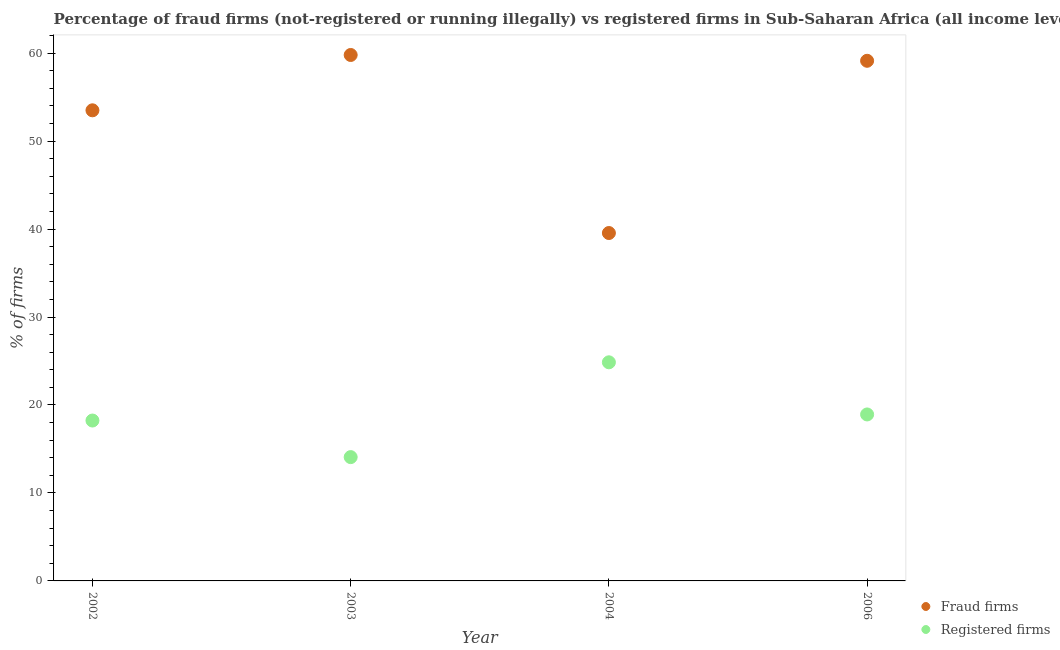How many different coloured dotlines are there?
Offer a very short reply. 2. Is the number of dotlines equal to the number of legend labels?
Offer a very short reply. Yes. What is the percentage of registered firms in 2002?
Provide a short and direct response. 18.23. Across all years, what is the maximum percentage of registered firms?
Offer a very short reply. 24.85. Across all years, what is the minimum percentage of fraud firms?
Give a very brief answer. 39.55. In which year was the percentage of fraud firms minimum?
Your response must be concise. 2004. What is the total percentage of fraud firms in the graph?
Your answer should be compact. 211.97. What is the difference between the percentage of registered firms in 2003 and that in 2006?
Offer a terse response. -4.85. What is the difference between the percentage of registered firms in 2003 and the percentage of fraud firms in 2004?
Your answer should be very brief. -25.47. What is the average percentage of registered firms per year?
Make the answer very short. 19.02. In the year 2002, what is the difference between the percentage of fraud firms and percentage of registered firms?
Your answer should be compact. 35.27. What is the ratio of the percentage of registered firms in 2004 to that in 2006?
Your answer should be compact. 1.31. Is the difference between the percentage of registered firms in 2003 and 2004 greater than the difference between the percentage of fraud firms in 2003 and 2004?
Give a very brief answer. No. What is the difference between the highest and the second highest percentage of registered firms?
Make the answer very short. 5.93. What is the difference between the highest and the lowest percentage of fraud firms?
Your response must be concise. 20.24. Is the sum of the percentage of fraud firms in 2002 and 2006 greater than the maximum percentage of registered firms across all years?
Ensure brevity in your answer.  Yes. Does the percentage of fraud firms monotonically increase over the years?
Give a very brief answer. No. Is the percentage of registered firms strictly greater than the percentage of fraud firms over the years?
Ensure brevity in your answer.  No. Is the percentage of fraud firms strictly less than the percentage of registered firms over the years?
Ensure brevity in your answer.  No. How many dotlines are there?
Your response must be concise. 2. Are the values on the major ticks of Y-axis written in scientific E-notation?
Your response must be concise. No. Does the graph contain any zero values?
Your answer should be compact. No. Does the graph contain grids?
Your answer should be compact. No. How many legend labels are there?
Give a very brief answer. 2. How are the legend labels stacked?
Keep it short and to the point. Vertical. What is the title of the graph?
Your answer should be very brief. Percentage of fraud firms (not-registered or running illegally) vs registered firms in Sub-Saharan Africa (all income levels). Does "Nitrous oxide" appear as one of the legend labels in the graph?
Your answer should be very brief. No. What is the label or title of the X-axis?
Offer a terse response. Year. What is the label or title of the Y-axis?
Keep it short and to the point. % of firms. What is the % of firms of Fraud firms in 2002?
Your answer should be very brief. 53.5. What is the % of firms in Registered firms in 2002?
Offer a terse response. 18.23. What is the % of firms in Fraud firms in 2003?
Keep it short and to the point. 59.79. What is the % of firms in Registered firms in 2003?
Your answer should be very brief. 14.07. What is the % of firms in Fraud firms in 2004?
Make the answer very short. 39.55. What is the % of firms in Registered firms in 2004?
Ensure brevity in your answer.  24.85. What is the % of firms of Fraud firms in 2006?
Your response must be concise. 59.13. What is the % of firms in Registered firms in 2006?
Offer a terse response. 18.93. Across all years, what is the maximum % of firms of Fraud firms?
Your answer should be compact. 59.79. Across all years, what is the maximum % of firms in Registered firms?
Offer a very short reply. 24.85. Across all years, what is the minimum % of firms in Fraud firms?
Ensure brevity in your answer.  39.55. Across all years, what is the minimum % of firms of Registered firms?
Offer a very short reply. 14.07. What is the total % of firms in Fraud firms in the graph?
Ensure brevity in your answer.  211.97. What is the total % of firms in Registered firms in the graph?
Make the answer very short. 76.09. What is the difference between the % of firms of Fraud firms in 2002 and that in 2003?
Make the answer very short. -6.29. What is the difference between the % of firms in Registered firms in 2002 and that in 2003?
Your answer should be very brief. 4.16. What is the difference between the % of firms of Fraud firms in 2002 and that in 2004?
Provide a succinct answer. 13.95. What is the difference between the % of firms in Registered firms in 2002 and that in 2004?
Give a very brief answer. -6.62. What is the difference between the % of firms of Fraud firms in 2002 and that in 2006?
Give a very brief answer. -5.63. What is the difference between the % of firms of Registered firms in 2002 and that in 2006?
Give a very brief answer. -0.69. What is the difference between the % of firms of Fraud firms in 2003 and that in 2004?
Make the answer very short. 20.24. What is the difference between the % of firms of Registered firms in 2003 and that in 2004?
Provide a succinct answer. -10.78. What is the difference between the % of firms in Fraud firms in 2003 and that in 2006?
Give a very brief answer. 0.66. What is the difference between the % of firms of Registered firms in 2003 and that in 2006?
Provide a short and direct response. -4.85. What is the difference between the % of firms in Fraud firms in 2004 and that in 2006?
Offer a very short reply. -19.58. What is the difference between the % of firms in Registered firms in 2004 and that in 2006?
Your response must be concise. 5.93. What is the difference between the % of firms in Fraud firms in 2002 and the % of firms in Registered firms in 2003?
Provide a short and direct response. 39.42. What is the difference between the % of firms in Fraud firms in 2002 and the % of firms in Registered firms in 2004?
Your answer should be compact. 28.65. What is the difference between the % of firms of Fraud firms in 2002 and the % of firms of Registered firms in 2006?
Your response must be concise. 34.58. What is the difference between the % of firms in Fraud firms in 2003 and the % of firms in Registered firms in 2004?
Your response must be concise. 34.94. What is the difference between the % of firms in Fraud firms in 2003 and the % of firms in Registered firms in 2006?
Your answer should be very brief. 40.87. What is the difference between the % of firms in Fraud firms in 2004 and the % of firms in Registered firms in 2006?
Your answer should be very brief. 20.62. What is the average % of firms in Fraud firms per year?
Ensure brevity in your answer.  52.99. What is the average % of firms in Registered firms per year?
Your answer should be very brief. 19.02. In the year 2002, what is the difference between the % of firms in Fraud firms and % of firms in Registered firms?
Ensure brevity in your answer.  35.27. In the year 2003, what is the difference between the % of firms of Fraud firms and % of firms of Registered firms?
Your answer should be compact. 45.72. In the year 2004, what is the difference between the % of firms of Fraud firms and % of firms of Registered firms?
Provide a short and direct response. 14.7. In the year 2006, what is the difference between the % of firms in Fraud firms and % of firms in Registered firms?
Your response must be concise. 40.2. What is the ratio of the % of firms of Fraud firms in 2002 to that in 2003?
Your answer should be compact. 0.89. What is the ratio of the % of firms of Registered firms in 2002 to that in 2003?
Offer a very short reply. 1.3. What is the ratio of the % of firms of Fraud firms in 2002 to that in 2004?
Your response must be concise. 1.35. What is the ratio of the % of firms in Registered firms in 2002 to that in 2004?
Your answer should be compact. 0.73. What is the ratio of the % of firms of Fraud firms in 2002 to that in 2006?
Keep it short and to the point. 0.9. What is the ratio of the % of firms in Registered firms in 2002 to that in 2006?
Offer a terse response. 0.96. What is the ratio of the % of firms in Fraud firms in 2003 to that in 2004?
Offer a very short reply. 1.51. What is the ratio of the % of firms in Registered firms in 2003 to that in 2004?
Offer a terse response. 0.57. What is the ratio of the % of firms in Fraud firms in 2003 to that in 2006?
Offer a very short reply. 1.01. What is the ratio of the % of firms of Registered firms in 2003 to that in 2006?
Offer a terse response. 0.74. What is the ratio of the % of firms in Fraud firms in 2004 to that in 2006?
Your response must be concise. 0.67. What is the ratio of the % of firms in Registered firms in 2004 to that in 2006?
Keep it short and to the point. 1.31. What is the difference between the highest and the second highest % of firms of Fraud firms?
Your response must be concise. 0.66. What is the difference between the highest and the second highest % of firms of Registered firms?
Keep it short and to the point. 5.93. What is the difference between the highest and the lowest % of firms of Fraud firms?
Your answer should be compact. 20.24. What is the difference between the highest and the lowest % of firms in Registered firms?
Offer a terse response. 10.78. 